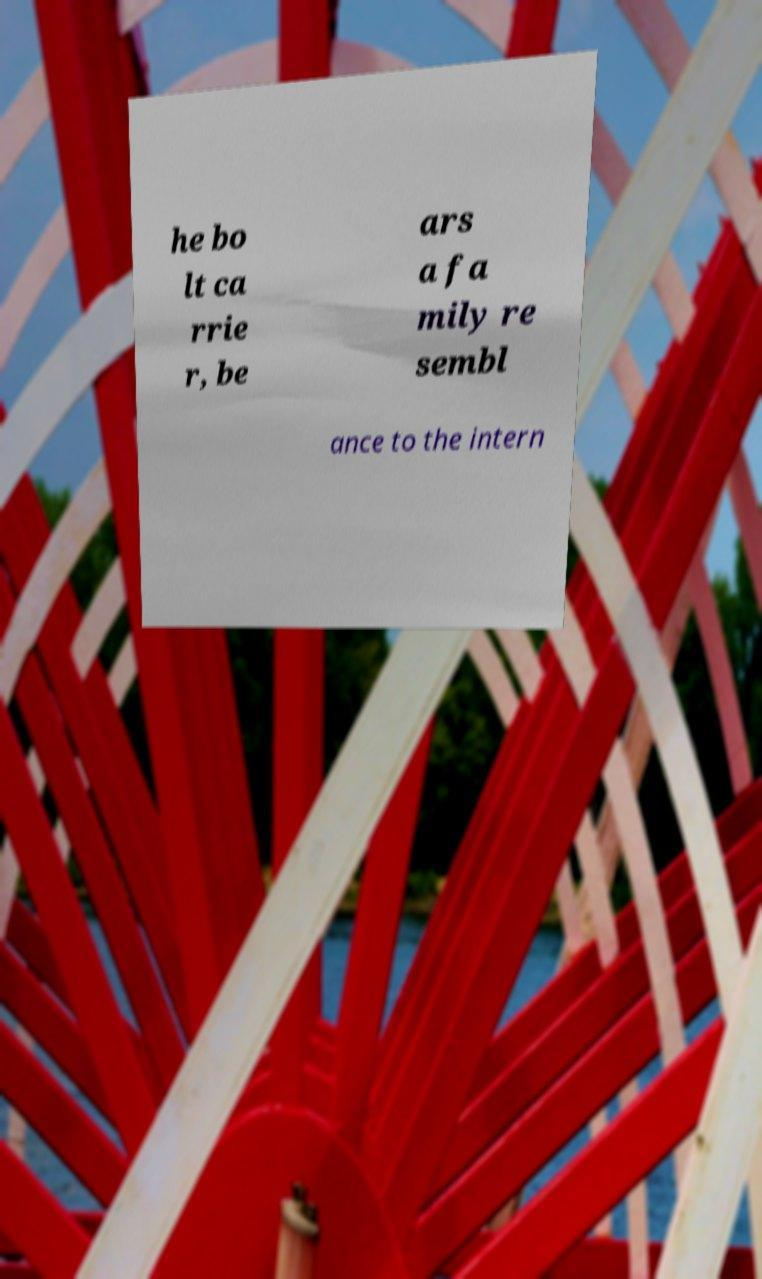I need the written content from this picture converted into text. Can you do that? he bo lt ca rrie r, be ars a fa mily re sembl ance to the intern 